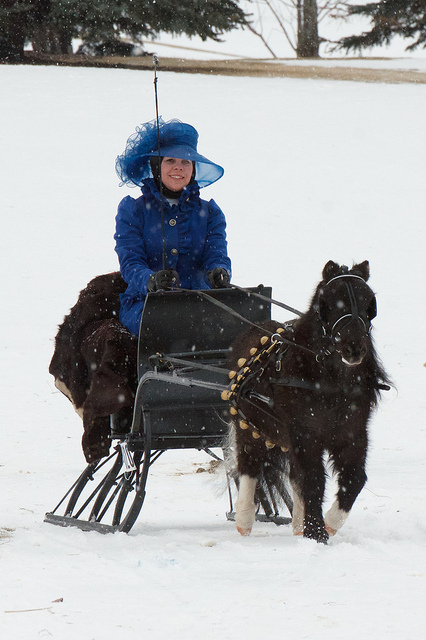Is there something unique about the horse in the image? Yes, the horse in the image is actually a small, sturdy pony, likely a breed well-suited for cold weather and pulling sleds. 